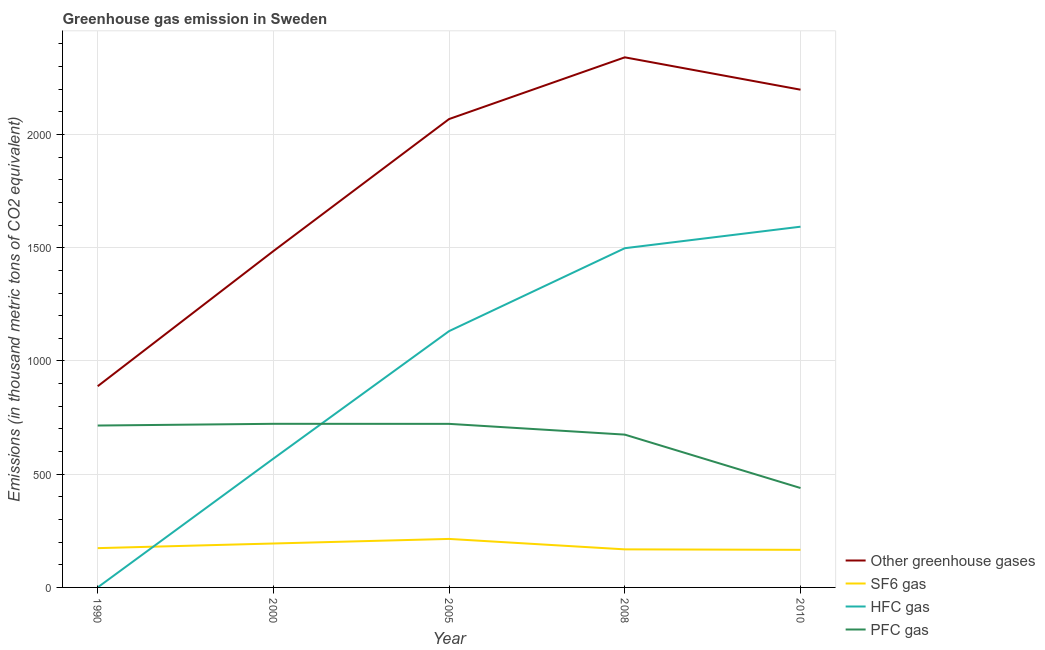What is the emission of greenhouse gases in 2000?
Give a very brief answer. 1485.3. Across all years, what is the maximum emission of pfc gas?
Your answer should be very brief. 722.5. What is the total emission of pfc gas in the graph?
Your response must be concise. 3273.5. What is the difference between the emission of pfc gas in 2008 and that in 2010?
Ensure brevity in your answer.  235.8. What is the difference between the emission of greenhouse gases in 2005 and the emission of hfc gas in 2008?
Provide a short and direct response. 570.4. What is the average emission of sf6 gas per year?
Ensure brevity in your answer.  183.16. In the year 2010, what is the difference between the emission of sf6 gas and emission of pfc gas?
Your response must be concise. -273. In how many years, is the emission of pfc gas greater than 800 thousand metric tons?
Offer a terse response. 0. What is the ratio of the emission of pfc gas in 2000 to that in 2005?
Ensure brevity in your answer.  1. What is the difference between the highest and the second highest emission of pfc gas?
Keep it short and to the point. 0.2. What is the difference between the highest and the lowest emission of hfc gas?
Your response must be concise. 1592.8. In how many years, is the emission of pfc gas greater than the average emission of pfc gas taken over all years?
Offer a terse response. 4. Is the sum of the emission of hfc gas in 2005 and 2008 greater than the maximum emission of sf6 gas across all years?
Your answer should be compact. Yes. Is it the case that in every year, the sum of the emission of greenhouse gases and emission of sf6 gas is greater than the emission of hfc gas?
Keep it short and to the point. Yes. Is the emission of greenhouse gases strictly greater than the emission of pfc gas over the years?
Give a very brief answer. Yes. Is the emission of pfc gas strictly less than the emission of sf6 gas over the years?
Keep it short and to the point. No. How many lines are there?
Provide a short and direct response. 4. What is the difference between two consecutive major ticks on the Y-axis?
Make the answer very short. 500. Does the graph contain any zero values?
Your answer should be very brief. No. Does the graph contain grids?
Offer a very short reply. Yes. Where does the legend appear in the graph?
Your answer should be compact. Bottom right. What is the title of the graph?
Your response must be concise. Greenhouse gas emission in Sweden. Does "Secondary schools" appear as one of the legend labels in the graph?
Keep it short and to the point. No. What is the label or title of the Y-axis?
Offer a very short reply. Emissions (in thousand metric tons of CO2 equivalent). What is the Emissions (in thousand metric tons of CO2 equivalent) in Other greenhouse gases in 1990?
Offer a very short reply. 888.6. What is the Emissions (in thousand metric tons of CO2 equivalent) in SF6 gas in 1990?
Offer a terse response. 173.5. What is the Emissions (in thousand metric tons of CO2 equivalent) of HFC gas in 1990?
Your response must be concise. 0.2. What is the Emissions (in thousand metric tons of CO2 equivalent) in PFC gas in 1990?
Offer a terse response. 714.9. What is the Emissions (in thousand metric tons of CO2 equivalent) in Other greenhouse gases in 2000?
Provide a short and direct response. 1485.3. What is the Emissions (in thousand metric tons of CO2 equivalent) of SF6 gas in 2000?
Your response must be concise. 194. What is the Emissions (in thousand metric tons of CO2 equivalent) in HFC gas in 2000?
Your answer should be very brief. 568.8. What is the Emissions (in thousand metric tons of CO2 equivalent) of PFC gas in 2000?
Give a very brief answer. 722.5. What is the Emissions (in thousand metric tons of CO2 equivalent) in Other greenhouse gases in 2005?
Your answer should be compact. 2068.4. What is the Emissions (in thousand metric tons of CO2 equivalent) of SF6 gas in 2005?
Provide a short and direct response. 214.2. What is the Emissions (in thousand metric tons of CO2 equivalent) of HFC gas in 2005?
Keep it short and to the point. 1131.9. What is the Emissions (in thousand metric tons of CO2 equivalent) of PFC gas in 2005?
Ensure brevity in your answer.  722.3. What is the Emissions (in thousand metric tons of CO2 equivalent) in Other greenhouse gases in 2008?
Offer a terse response. 2340.9. What is the Emissions (in thousand metric tons of CO2 equivalent) of SF6 gas in 2008?
Offer a terse response. 168.1. What is the Emissions (in thousand metric tons of CO2 equivalent) in HFC gas in 2008?
Offer a very short reply. 1498. What is the Emissions (in thousand metric tons of CO2 equivalent) of PFC gas in 2008?
Your answer should be very brief. 674.8. What is the Emissions (in thousand metric tons of CO2 equivalent) of Other greenhouse gases in 2010?
Ensure brevity in your answer.  2198. What is the Emissions (in thousand metric tons of CO2 equivalent) in SF6 gas in 2010?
Make the answer very short. 166. What is the Emissions (in thousand metric tons of CO2 equivalent) in HFC gas in 2010?
Your answer should be very brief. 1593. What is the Emissions (in thousand metric tons of CO2 equivalent) in PFC gas in 2010?
Your response must be concise. 439. Across all years, what is the maximum Emissions (in thousand metric tons of CO2 equivalent) in Other greenhouse gases?
Offer a terse response. 2340.9. Across all years, what is the maximum Emissions (in thousand metric tons of CO2 equivalent) in SF6 gas?
Ensure brevity in your answer.  214.2. Across all years, what is the maximum Emissions (in thousand metric tons of CO2 equivalent) of HFC gas?
Your response must be concise. 1593. Across all years, what is the maximum Emissions (in thousand metric tons of CO2 equivalent) in PFC gas?
Give a very brief answer. 722.5. Across all years, what is the minimum Emissions (in thousand metric tons of CO2 equivalent) in Other greenhouse gases?
Provide a succinct answer. 888.6. Across all years, what is the minimum Emissions (in thousand metric tons of CO2 equivalent) in SF6 gas?
Your answer should be very brief. 166. Across all years, what is the minimum Emissions (in thousand metric tons of CO2 equivalent) in PFC gas?
Ensure brevity in your answer.  439. What is the total Emissions (in thousand metric tons of CO2 equivalent) of Other greenhouse gases in the graph?
Offer a terse response. 8981.2. What is the total Emissions (in thousand metric tons of CO2 equivalent) in SF6 gas in the graph?
Ensure brevity in your answer.  915.8. What is the total Emissions (in thousand metric tons of CO2 equivalent) of HFC gas in the graph?
Offer a terse response. 4791.9. What is the total Emissions (in thousand metric tons of CO2 equivalent) in PFC gas in the graph?
Your response must be concise. 3273.5. What is the difference between the Emissions (in thousand metric tons of CO2 equivalent) in Other greenhouse gases in 1990 and that in 2000?
Your response must be concise. -596.7. What is the difference between the Emissions (in thousand metric tons of CO2 equivalent) of SF6 gas in 1990 and that in 2000?
Give a very brief answer. -20.5. What is the difference between the Emissions (in thousand metric tons of CO2 equivalent) of HFC gas in 1990 and that in 2000?
Your answer should be compact. -568.6. What is the difference between the Emissions (in thousand metric tons of CO2 equivalent) of Other greenhouse gases in 1990 and that in 2005?
Provide a short and direct response. -1179.8. What is the difference between the Emissions (in thousand metric tons of CO2 equivalent) in SF6 gas in 1990 and that in 2005?
Ensure brevity in your answer.  -40.7. What is the difference between the Emissions (in thousand metric tons of CO2 equivalent) of HFC gas in 1990 and that in 2005?
Provide a short and direct response. -1131.7. What is the difference between the Emissions (in thousand metric tons of CO2 equivalent) of Other greenhouse gases in 1990 and that in 2008?
Keep it short and to the point. -1452.3. What is the difference between the Emissions (in thousand metric tons of CO2 equivalent) of SF6 gas in 1990 and that in 2008?
Your response must be concise. 5.4. What is the difference between the Emissions (in thousand metric tons of CO2 equivalent) of HFC gas in 1990 and that in 2008?
Your answer should be very brief. -1497.8. What is the difference between the Emissions (in thousand metric tons of CO2 equivalent) of PFC gas in 1990 and that in 2008?
Provide a short and direct response. 40.1. What is the difference between the Emissions (in thousand metric tons of CO2 equivalent) of Other greenhouse gases in 1990 and that in 2010?
Your answer should be compact. -1309.4. What is the difference between the Emissions (in thousand metric tons of CO2 equivalent) of HFC gas in 1990 and that in 2010?
Your answer should be compact. -1592.8. What is the difference between the Emissions (in thousand metric tons of CO2 equivalent) in PFC gas in 1990 and that in 2010?
Keep it short and to the point. 275.9. What is the difference between the Emissions (in thousand metric tons of CO2 equivalent) of Other greenhouse gases in 2000 and that in 2005?
Keep it short and to the point. -583.1. What is the difference between the Emissions (in thousand metric tons of CO2 equivalent) in SF6 gas in 2000 and that in 2005?
Offer a very short reply. -20.2. What is the difference between the Emissions (in thousand metric tons of CO2 equivalent) in HFC gas in 2000 and that in 2005?
Your response must be concise. -563.1. What is the difference between the Emissions (in thousand metric tons of CO2 equivalent) in Other greenhouse gases in 2000 and that in 2008?
Your response must be concise. -855.6. What is the difference between the Emissions (in thousand metric tons of CO2 equivalent) in SF6 gas in 2000 and that in 2008?
Provide a short and direct response. 25.9. What is the difference between the Emissions (in thousand metric tons of CO2 equivalent) in HFC gas in 2000 and that in 2008?
Offer a very short reply. -929.2. What is the difference between the Emissions (in thousand metric tons of CO2 equivalent) in PFC gas in 2000 and that in 2008?
Make the answer very short. 47.7. What is the difference between the Emissions (in thousand metric tons of CO2 equivalent) of Other greenhouse gases in 2000 and that in 2010?
Offer a terse response. -712.7. What is the difference between the Emissions (in thousand metric tons of CO2 equivalent) of HFC gas in 2000 and that in 2010?
Make the answer very short. -1024.2. What is the difference between the Emissions (in thousand metric tons of CO2 equivalent) of PFC gas in 2000 and that in 2010?
Your answer should be very brief. 283.5. What is the difference between the Emissions (in thousand metric tons of CO2 equivalent) of Other greenhouse gases in 2005 and that in 2008?
Your answer should be very brief. -272.5. What is the difference between the Emissions (in thousand metric tons of CO2 equivalent) of SF6 gas in 2005 and that in 2008?
Offer a terse response. 46.1. What is the difference between the Emissions (in thousand metric tons of CO2 equivalent) of HFC gas in 2005 and that in 2008?
Provide a succinct answer. -366.1. What is the difference between the Emissions (in thousand metric tons of CO2 equivalent) in PFC gas in 2005 and that in 2008?
Your response must be concise. 47.5. What is the difference between the Emissions (in thousand metric tons of CO2 equivalent) of Other greenhouse gases in 2005 and that in 2010?
Your answer should be compact. -129.6. What is the difference between the Emissions (in thousand metric tons of CO2 equivalent) in SF6 gas in 2005 and that in 2010?
Provide a succinct answer. 48.2. What is the difference between the Emissions (in thousand metric tons of CO2 equivalent) in HFC gas in 2005 and that in 2010?
Give a very brief answer. -461.1. What is the difference between the Emissions (in thousand metric tons of CO2 equivalent) in PFC gas in 2005 and that in 2010?
Your answer should be very brief. 283.3. What is the difference between the Emissions (in thousand metric tons of CO2 equivalent) of Other greenhouse gases in 2008 and that in 2010?
Provide a succinct answer. 142.9. What is the difference between the Emissions (in thousand metric tons of CO2 equivalent) in HFC gas in 2008 and that in 2010?
Keep it short and to the point. -95. What is the difference between the Emissions (in thousand metric tons of CO2 equivalent) in PFC gas in 2008 and that in 2010?
Offer a terse response. 235.8. What is the difference between the Emissions (in thousand metric tons of CO2 equivalent) in Other greenhouse gases in 1990 and the Emissions (in thousand metric tons of CO2 equivalent) in SF6 gas in 2000?
Provide a short and direct response. 694.6. What is the difference between the Emissions (in thousand metric tons of CO2 equivalent) in Other greenhouse gases in 1990 and the Emissions (in thousand metric tons of CO2 equivalent) in HFC gas in 2000?
Provide a succinct answer. 319.8. What is the difference between the Emissions (in thousand metric tons of CO2 equivalent) in Other greenhouse gases in 1990 and the Emissions (in thousand metric tons of CO2 equivalent) in PFC gas in 2000?
Ensure brevity in your answer.  166.1. What is the difference between the Emissions (in thousand metric tons of CO2 equivalent) of SF6 gas in 1990 and the Emissions (in thousand metric tons of CO2 equivalent) of HFC gas in 2000?
Keep it short and to the point. -395.3. What is the difference between the Emissions (in thousand metric tons of CO2 equivalent) in SF6 gas in 1990 and the Emissions (in thousand metric tons of CO2 equivalent) in PFC gas in 2000?
Make the answer very short. -549. What is the difference between the Emissions (in thousand metric tons of CO2 equivalent) of HFC gas in 1990 and the Emissions (in thousand metric tons of CO2 equivalent) of PFC gas in 2000?
Ensure brevity in your answer.  -722.3. What is the difference between the Emissions (in thousand metric tons of CO2 equivalent) in Other greenhouse gases in 1990 and the Emissions (in thousand metric tons of CO2 equivalent) in SF6 gas in 2005?
Your response must be concise. 674.4. What is the difference between the Emissions (in thousand metric tons of CO2 equivalent) in Other greenhouse gases in 1990 and the Emissions (in thousand metric tons of CO2 equivalent) in HFC gas in 2005?
Make the answer very short. -243.3. What is the difference between the Emissions (in thousand metric tons of CO2 equivalent) of Other greenhouse gases in 1990 and the Emissions (in thousand metric tons of CO2 equivalent) of PFC gas in 2005?
Make the answer very short. 166.3. What is the difference between the Emissions (in thousand metric tons of CO2 equivalent) in SF6 gas in 1990 and the Emissions (in thousand metric tons of CO2 equivalent) in HFC gas in 2005?
Provide a short and direct response. -958.4. What is the difference between the Emissions (in thousand metric tons of CO2 equivalent) of SF6 gas in 1990 and the Emissions (in thousand metric tons of CO2 equivalent) of PFC gas in 2005?
Provide a succinct answer. -548.8. What is the difference between the Emissions (in thousand metric tons of CO2 equivalent) of HFC gas in 1990 and the Emissions (in thousand metric tons of CO2 equivalent) of PFC gas in 2005?
Provide a short and direct response. -722.1. What is the difference between the Emissions (in thousand metric tons of CO2 equivalent) in Other greenhouse gases in 1990 and the Emissions (in thousand metric tons of CO2 equivalent) in SF6 gas in 2008?
Your answer should be very brief. 720.5. What is the difference between the Emissions (in thousand metric tons of CO2 equivalent) in Other greenhouse gases in 1990 and the Emissions (in thousand metric tons of CO2 equivalent) in HFC gas in 2008?
Keep it short and to the point. -609.4. What is the difference between the Emissions (in thousand metric tons of CO2 equivalent) in Other greenhouse gases in 1990 and the Emissions (in thousand metric tons of CO2 equivalent) in PFC gas in 2008?
Provide a succinct answer. 213.8. What is the difference between the Emissions (in thousand metric tons of CO2 equivalent) in SF6 gas in 1990 and the Emissions (in thousand metric tons of CO2 equivalent) in HFC gas in 2008?
Provide a succinct answer. -1324.5. What is the difference between the Emissions (in thousand metric tons of CO2 equivalent) of SF6 gas in 1990 and the Emissions (in thousand metric tons of CO2 equivalent) of PFC gas in 2008?
Offer a terse response. -501.3. What is the difference between the Emissions (in thousand metric tons of CO2 equivalent) in HFC gas in 1990 and the Emissions (in thousand metric tons of CO2 equivalent) in PFC gas in 2008?
Your response must be concise. -674.6. What is the difference between the Emissions (in thousand metric tons of CO2 equivalent) in Other greenhouse gases in 1990 and the Emissions (in thousand metric tons of CO2 equivalent) in SF6 gas in 2010?
Offer a terse response. 722.6. What is the difference between the Emissions (in thousand metric tons of CO2 equivalent) in Other greenhouse gases in 1990 and the Emissions (in thousand metric tons of CO2 equivalent) in HFC gas in 2010?
Offer a very short reply. -704.4. What is the difference between the Emissions (in thousand metric tons of CO2 equivalent) in Other greenhouse gases in 1990 and the Emissions (in thousand metric tons of CO2 equivalent) in PFC gas in 2010?
Ensure brevity in your answer.  449.6. What is the difference between the Emissions (in thousand metric tons of CO2 equivalent) of SF6 gas in 1990 and the Emissions (in thousand metric tons of CO2 equivalent) of HFC gas in 2010?
Ensure brevity in your answer.  -1419.5. What is the difference between the Emissions (in thousand metric tons of CO2 equivalent) of SF6 gas in 1990 and the Emissions (in thousand metric tons of CO2 equivalent) of PFC gas in 2010?
Your answer should be very brief. -265.5. What is the difference between the Emissions (in thousand metric tons of CO2 equivalent) in HFC gas in 1990 and the Emissions (in thousand metric tons of CO2 equivalent) in PFC gas in 2010?
Ensure brevity in your answer.  -438.8. What is the difference between the Emissions (in thousand metric tons of CO2 equivalent) in Other greenhouse gases in 2000 and the Emissions (in thousand metric tons of CO2 equivalent) in SF6 gas in 2005?
Your answer should be very brief. 1271.1. What is the difference between the Emissions (in thousand metric tons of CO2 equivalent) in Other greenhouse gases in 2000 and the Emissions (in thousand metric tons of CO2 equivalent) in HFC gas in 2005?
Provide a short and direct response. 353.4. What is the difference between the Emissions (in thousand metric tons of CO2 equivalent) in Other greenhouse gases in 2000 and the Emissions (in thousand metric tons of CO2 equivalent) in PFC gas in 2005?
Provide a succinct answer. 763. What is the difference between the Emissions (in thousand metric tons of CO2 equivalent) in SF6 gas in 2000 and the Emissions (in thousand metric tons of CO2 equivalent) in HFC gas in 2005?
Your response must be concise. -937.9. What is the difference between the Emissions (in thousand metric tons of CO2 equivalent) of SF6 gas in 2000 and the Emissions (in thousand metric tons of CO2 equivalent) of PFC gas in 2005?
Your answer should be compact. -528.3. What is the difference between the Emissions (in thousand metric tons of CO2 equivalent) of HFC gas in 2000 and the Emissions (in thousand metric tons of CO2 equivalent) of PFC gas in 2005?
Your response must be concise. -153.5. What is the difference between the Emissions (in thousand metric tons of CO2 equivalent) of Other greenhouse gases in 2000 and the Emissions (in thousand metric tons of CO2 equivalent) of SF6 gas in 2008?
Your answer should be compact. 1317.2. What is the difference between the Emissions (in thousand metric tons of CO2 equivalent) in Other greenhouse gases in 2000 and the Emissions (in thousand metric tons of CO2 equivalent) in PFC gas in 2008?
Your response must be concise. 810.5. What is the difference between the Emissions (in thousand metric tons of CO2 equivalent) of SF6 gas in 2000 and the Emissions (in thousand metric tons of CO2 equivalent) of HFC gas in 2008?
Give a very brief answer. -1304. What is the difference between the Emissions (in thousand metric tons of CO2 equivalent) in SF6 gas in 2000 and the Emissions (in thousand metric tons of CO2 equivalent) in PFC gas in 2008?
Offer a very short reply. -480.8. What is the difference between the Emissions (in thousand metric tons of CO2 equivalent) in HFC gas in 2000 and the Emissions (in thousand metric tons of CO2 equivalent) in PFC gas in 2008?
Offer a terse response. -106. What is the difference between the Emissions (in thousand metric tons of CO2 equivalent) in Other greenhouse gases in 2000 and the Emissions (in thousand metric tons of CO2 equivalent) in SF6 gas in 2010?
Offer a terse response. 1319.3. What is the difference between the Emissions (in thousand metric tons of CO2 equivalent) of Other greenhouse gases in 2000 and the Emissions (in thousand metric tons of CO2 equivalent) of HFC gas in 2010?
Give a very brief answer. -107.7. What is the difference between the Emissions (in thousand metric tons of CO2 equivalent) in Other greenhouse gases in 2000 and the Emissions (in thousand metric tons of CO2 equivalent) in PFC gas in 2010?
Make the answer very short. 1046.3. What is the difference between the Emissions (in thousand metric tons of CO2 equivalent) of SF6 gas in 2000 and the Emissions (in thousand metric tons of CO2 equivalent) of HFC gas in 2010?
Your answer should be compact. -1399. What is the difference between the Emissions (in thousand metric tons of CO2 equivalent) of SF6 gas in 2000 and the Emissions (in thousand metric tons of CO2 equivalent) of PFC gas in 2010?
Give a very brief answer. -245. What is the difference between the Emissions (in thousand metric tons of CO2 equivalent) in HFC gas in 2000 and the Emissions (in thousand metric tons of CO2 equivalent) in PFC gas in 2010?
Your answer should be compact. 129.8. What is the difference between the Emissions (in thousand metric tons of CO2 equivalent) of Other greenhouse gases in 2005 and the Emissions (in thousand metric tons of CO2 equivalent) of SF6 gas in 2008?
Offer a terse response. 1900.3. What is the difference between the Emissions (in thousand metric tons of CO2 equivalent) in Other greenhouse gases in 2005 and the Emissions (in thousand metric tons of CO2 equivalent) in HFC gas in 2008?
Your answer should be very brief. 570.4. What is the difference between the Emissions (in thousand metric tons of CO2 equivalent) of Other greenhouse gases in 2005 and the Emissions (in thousand metric tons of CO2 equivalent) of PFC gas in 2008?
Your answer should be very brief. 1393.6. What is the difference between the Emissions (in thousand metric tons of CO2 equivalent) in SF6 gas in 2005 and the Emissions (in thousand metric tons of CO2 equivalent) in HFC gas in 2008?
Provide a succinct answer. -1283.8. What is the difference between the Emissions (in thousand metric tons of CO2 equivalent) in SF6 gas in 2005 and the Emissions (in thousand metric tons of CO2 equivalent) in PFC gas in 2008?
Provide a succinct answer. -460.6. What is the difference between the Emissions (in thousand metric tons of CO2 equivalent) of HFC gas in 2005 and the Emissions (in thousand metric tons of CO2 equivalent) of PFC gas in 2008?
Your response must be concise. 457.1. What is the difference between the Emissions (in thousand metric tons of CO2 equivalent) of Other greenhouse gases in 2005 and the Emissions (in thousand metric tons of CO2 equivalent) of SF6 gas in 2010?
Ensure brevity in your answer.  1902.4. What is the difference between the Emissions (in thousand metric tons of CO2 equivalent) of Other greenhouse gases in 2005 and the Emissions (in thousand metric tons of CO2 equivalent) of HFC gas in 2010?
Keep it short and to the point. 475.4. What is the difference between the Emissions (in thousand metric tons of CO2 equivalent) of Other greenhouse gases in 2005 and the Emissions (in thousand metric tons of CO2 equivalent) of PFC gas in 2010?
Provide a succinct answer. 1629.4. What is the difference between the Emissions (in thousand metric tons of CO2 equivalent) in SF6 gas in 2005 and the Emissions (in thousand metric tons of CO2 equivalent) in HFC gas in 2010?
Provide a short and direct response. -1378.8. What is the difference between the Emissions (in thousand metric tons of CO2 equivalent) of SF6 gas in 2005 and the Emissions (in thousand metric tons of CO2 equivalent) of PFC gas in 2010?
Your answer should be very brief. -224.8. What is the difference between the Emissions (in thousand metric tons of CO2 equivalent) in HFC gas in 2005 and the Emissions (in thousand metric tons of CO2 equivalent) in PFC gas in 2010?
Keep it short and to the point. 692.9. What is the difference between the Emissions (in thousand metric tons of CO2 equivalent) in Other greenhouse gases in 2008 and the Emissions (in thousand metric tons of CO2 equivalent) in SF6 gas in 2010?
Make the answer very short. 2174.9. What is the difference between the Emissions (in thousand metric tons of CO2 equivalent) of Other greenhouse gases in 2008 and the Emissions (in thousand metric tons of CO2 equivalent) of HFC gas in 2010?
Provide a succinct answer. 747.9. What is the difference between the Emissions (in thousand metric tons of CO2 equivalent) of Other greenhouse gases in 2008 and the Emissions (in thousand metric tons of CO2 equivalent) of PFC gas in 2010?
Make the answer very short. 1901.9. What is the difference between the Emissions (in thousand metric tons of CO2 equivalent) of SF6 gas in 2008 and the Emissions (in thousand metric tons of CO2 equivalent) of HFC gas in 2010?
Make the answer very short. -1424.9. What is the difference between the Emissions (in thousand metric tons of CO2 equivalent) in SF6 gas in 2008 and the Emissions (in thousand metric tons of CO2 equivalent) in PFC gas in 2010?
Your response must be concise. -270.9. What is the difference between the Emissions (in thousand metric tons of CO2 equivalent) of HFC gas in 2008 and the Emissions (in thousand metric tons of CO2 equivalent) of PFC gas in 2010?
Make the answer very short. 1059. What is the average Emissions (in thousand metric tons of CO2 equivalent) of Other greenhouse gases per year?
Provide a succinct answer. 1796.24. What is the average Emissions (in thousand metric tons of CO2 equivalent) in SF6 gas per year?
Your answer should be compact. 183.16. What is the average Emissions (in thousand metric tons of CO2 equivalent) of HFC gas per year?
Provide a short and direct response. 958.38. What is the average Emissions (in thousand metric tons of CO2 equivalent) of PFC gas per year?
Keep it short and to the point. 654.7. In the year 1990, what is the difference between the Emissions (in thousand metric tons of CO2 equivalent) of Other greenhouse gases and Emissions (in thousand metric tons of CO2 equivalent) of SF6 gas?
Provide a short and direct response. 715.1. In the year 1990, what is the difference between the Emissions (in thousand metric tons of CO2 equivalent) in Other greenhouse gases and Emissions (in thousand metric tons of CO2 equivalent) in HFC gas?
Offer a terse response. 888.4. In the year 1990, what is the difference between the Emissions (in thousand metric tons of CO2 equivalent) in Other greenhouse gases and Emissions (in thousand metric tons of CO2 equivalent) in PFC gas?
Make the answer very short. 173.7. In the year 1990, what is the difference between the Emissions (in thousand metric tons of CO2 equivalent) in SF6 gas and Emissions (in thousand metric tons of CO2 equivalent) in HFC gas?
Your answer should be very brief. 173.3. In the year 1990, what is the difference between the Emissions (in thousand metric tons of CO2 equivalent) in SF6 gas and Emissions (in thousand metric tons of CO2 equivalent) in PFC gas?
Provide a short and direct response. -541.4. In the year 1990, what is the difference between the Emissions (in thousand metric tons of CO2 equivalent) in HFC gas and Emissions (in thousand metric tons of CO2 equivalent) in PFC gas?
Give a very brief answer. -714.7. In the year 2000, what is the difference between the Emissions (in thousand metric tons of CO2 equivalent) of Other greenhouse gases and Emissions (in thousand metric tons of CO2 equivalent) of SF6 gas?
Make the answer very short. 1291.3. In the year 2000, what is the difference between the Emissions (in thousand metric tons of CO2 equivalent) in Other greenhouse gases and Emissions (in thousand metric tons of CO2 equivalent) in HFC gas?
Make the answer very short. 916.5. In the year 2000, what is the difference between the Emissions (in thousand metric tons of CO2 equivalent) in Other greenhouse gases and Emissions (in thousand metric tons of CO2 equivalent) in PFC gas?
Provide a succinct answer. 762.8. In the year 2000, what is the difference between the Emissions (in thousand metric tons of CO2 equivalent) in SF6 gas and Emissions (in thousand metric tons of CO2 equivalent) in HFC gas?
Make the answer very short. -374.8. In the year 2000, what is the difference between the Emissions (in thousand metric tons of CO2 equivalent) in SF6 gas and Emissions (in thousand metric tons of CO2 equivalent) in PFC gas?
Keep it short and to the point. -528.5. In the year 2000, what is the difference between the Emissions (in thousand metric tons of CO2 equivalent) in HFC gas and Emissions (in thousand metric tons of CO2 equivalent) in PFC gas?
Ensure brevity in your answer.  -153.7. In the year 2005, what is the difference between the Emissions (in thousand metric tons of CO2 equivalent) of Other greenhouse gases and Emissions (in thousand metric tons of CO2 equivalent) of SF6 gas?
Offer a very short reply. 1854.2. In the year 2005, what is the difference between the Emissions (in thousand metric tons of CO2 equivalent) of Other greenhouse gases and Emissions (in thousand metric tons of CO2 equivalent) of HFC gas?
Make the answer very short. 936.5. In the year 2005, what is the difference between the Emissions (in thousand metric tons of CO2 equivalent) in Other greenhouse gases and Emissions (in thousand metric tons of CO2 equivalent) in PFC gas?
Your answer should be very brief. 1346.1. In the year 2005, what is the difference between the Emissions (in thousand metric tons of CO2 equivalent) of SF6 gas and Emissions (in thousand metric tons of CO2 equivalent) of HFC gas?
Your answer should be very brief. -917.7. In the year 2005, what is the difference between the Emissions (in thousand metric tons of CO2 equivalent) in SF6 gas and Emissions (in thousand metric tons of CO2 equivalent) in PFC gas?
Offer a terse response. -508.1. In the year 2005, what is the difference between the Emissions (in thousand metric tons of CO2 equivalent) in HFC gas and Emissions (in thousand metric tons of CO2 equivalent) in PFC gas?
Offer a very short reply. 409.6. In the year 2008, what is the difference between the Emissions (in thousand metric tons of CO2 equivalent) in Other greenhouse gases and Emissions (in thousand metric tons of CO2 equivalent) in SF6 gas?
Make the answer very short. 2172.8. In the year 2008, what is the difference between the Emissions (in thousand metric tons of CO2 equivalent) in Other greenhouse gases and Emissions (in thousand metric tons of CO2 equivalent) in HFC gas?
Make the answer very short. 842.9. In the year 2008, what is the difference between the Emissions (in thousand metric tons of CO2 equivalent) in Other greenhouse gases and Emissions (in thousand metric tons of CO2 equivalent) in PFC gas?
Provide a short and direct response. 1666.1. In the year 2008, what is the difference between the Emissions (in thousand metric tons of CO2 equivalent) in SF6 gas and Emissions (in thousand metric tons of CO2 equivalent) in HFC gas?
Make the answer very short. -1329.9. In the year 2008, what is the difference between the Emissions (in thousand metric tons of CO2 equivalent) of SF6 gas and Emissions (in thousand metric tons of CO2 equivalent) of PFC gas?
Provide a succinct answer. -506.7. In the year 2008, what is the difference between the Emissions (in thousand metric tons of CO2 equivalent) of HFC gas and Emissions (in thousand metric tons of CO2 equivalent) of PFC gas?
Give a very brief answer. 823.2. In the year 2010, what is the difference between the Emissions (in thousand metric tons of CO2 equivalent) of Other greenhouse gases and Emissions (in thousand metric tons of CO2 equivalent) of SF6 gas?
Ensure brevity in your answer.  2032. In the year 2010, what is the difference between the Emissions (in thousand metric tons of CO2 equivalent) of Other greenhouse gases and Emissions (in thousand metric tons of CO2 equivalent) of HFC gas?
Give a very brief answer. 605. In the year 2010, what is the difference between the Emissions (in thousand metric tons of CO2 equivalent) in Other greenhouse gases and Emissions (in thousand metric tons of CO2 equivalent) in PFC gas?
Your response must be concise. 1759. In the year 2010, what is the difference between the Emissions (in thousand metric tons of CO2 equivalent) in SF6 gas and Emissions (in thousand metric tons of CO2 equivalent) in HFC gas?
Offer a terse response. -1427. In the year 2010, what is the difference between the Emissions (in thousand metric tons of CO2 equivalent) of SF6 gas and Emissions (in thousand metric tons of CO2 equivalent) of PFC gas?
Offer a terse response. -273. In the year 2010, what is the difference between the Emissions (in thousand metric tons of CO2 equivalent) in HFC gas and Emissions (in thousand metric tons of CO2 equivalent) in PFC gas?
Make the answer very short. 1154. What is the ratio of the Emissions (in thousand metric tons of CO2 equivalent) of Other greenhouse gases in 1990 to that in 2000?
Your answer should be compact. 0.6. What is the ratio of the Emissions (in thousand metric tons of CO2 equivalent) of SF6 gas in 1990 to that in 2000?
Offer a very short reply. 0.89. What is the ratio of the Emissions (in thousand metric tons of CO2 equivalent) of HFC gas in 1990 to that in 2000?
Offer a very short reply. 0. What is the ratio of the Emissions (in thousand metric tons of CO2 equivalent) in PFC gas in 1990 to that in 2000?
Provide a short and direct response. 0.99. What is the ratio of the Emissions (in thousand metric tons of CO2 equivalent) in Other greenhouse gases in 1990 to that in 2005?
Your response must be concise. 0.43. What is the ratio of the Emissions (in thousand metric tons of CO2 equivalent) of SF6 gas in 1990 to that in 2005?
Your response must be concise. 0.81. What is the ratio of the Emissions (in thousand metric tons of CO2 equivalent) of HFC gas in 1990 to that in 2005?
Offer a very short reply. 0. What is the ratio of the Emissions (in thousand metric tons of CO2 equivalent) of Other greenhouse gases in 1990 to that in 2008?
Your response must be concise. 0.38. What is the ratio of the Emissions (in thousand metric tons of CO2 equivalent) in SF6 gas in 1990 to that in 2008?
Your response must be concise. 1.03. What is the ratio of the Emissions (in thousand metric tons of CO2 equivalent) of PFC gas in 1990 to that in 2008?
Offer a terse response. 1.06. What is the ratio of the Emissions (in thousand metric tons of CO2 equivalent) in Other greenhouse gases in 1990 to that in 2010?
Offer a very short reply. 0.4. What is the ratio of the Emissions (in thousand metric tons of CO2 equivalent) of SF6 gas in 1990 to that in 2010?
Your answer should be compact. 1.05. What is the ratio of the Emissions (in thousand metric tons of CO2 equivalent) in PFC gas in 1990 to that in 2010?
Give a very brief answer. 1.63. What is the ratio of the Emissions (in thousand metric tons of CO2 equivalent) of Other greenhouse gases in 2000 to that in 2005?
Offer a very short reply. 0.72. What is the ratio of the Emissions (in thousand metric tons of CO2 equivalent) in SF6 gas in 2000 to that in 2005?
Give a very brief answer. 0.91. What is the ratio of the Emissions (in thousand metric tons of CO2 equivalent) in HFC gas in 2000 to that in 2005?
Give a very brief answer. 0.5. What is the ratio of the Emissions (in thousand metric tons of CO2 equivalent) of Other greenhouse gases in 2000 to that in 2008?
Make the answer very short. 0.63. What is the ratio of the Emissions (in thousand metric tons of CO2 equivalent) in SF6 gas in 2000 to that in 2008?
Offer a very short reply. 1.15. What is the ratio of the Emissions (in thousand metric tons of CO2 equivalent) in HFC gas in 2000 to that in 2008?
Your response must be concise. 0.38. What is the ratio of the Emissions (in thousand metric tons of CO2 equivalent) in PFC gas in 2000 to that in 2008?
Make the answer very short. 1.07. What is the ratio of the Emissions (in thousand metric tons of CO2 equivalent) in Other greenhouse gases in 2000 to that in 2010?
Your answer should be compact. 0.68. What is the ratio of the Emissions (in thousand metric tons of CO2 equivalent) of SF6 gas in 2000 to that in 2010?
Make the answer very short. 1.17. What is the ratio of the Emissions (in thousand metric tons of CO2 equivalent) in HFC gas in 2000 to that in 2010?
Offer a very short reply. 0.36. What is the ratio of the Emissions (in thousand metric tons of CO2 equivalent) in PFC gas in 2000 to that in 2010?
Provide a short and direct response. 1.65. What is the ratio of the Emissions (in thousand metric tons of CO2 equivalent) in Other greenhouse gases in 2005 to that in 2008?
Make the answer very short. 0.88. What is the ratio of the Emissions (in thousand metric tons of CO2 equivalent) in SF6 gas in 2005 to that in 2008?
Offer a very short reply. 1.27. What is the ratio of the Emissions (in thousand metric tons of CO2 equivalent) in HFC gas in 2005 to that in 2008?
Offer a very short reply. 0.76. What is the ratio of the Emissions (in thousand metric tons of CO2 equivalent) of PFC gas in 2005 to that in 2008?
Provide a succinct answer. 1.07. What is the ratio of the Emissions (in thousand metric tons of CO2 equivalent) in Other greenhouse gases in 2005 to that in 2010?
Provide a succinct answer. 0.94. What is the ratio of the Emissions (in thousand metric tons of CO2 equivalent) of SF6 gas in 2005 to that in 2010?
Give a very brief answer. 1.29. What is the ratio of the Emissions (in thousand metric tons of CO2 equivalent) in HFC gas in 2005 to that in 2010?
Make the answer very short. 0.71. What is the ratio of the Emissions (in thousand metric tons of CO2 equivalent) in PFC gas in 2005 to that in 2010?
Your answer should be compact. 1.65. What is the ratio of the Emissions (in thousand metric tons of CO2 equivalent) in Other greenhouse gases in 2008 to that in 2010?
Offer a very short reply. 1.06. What is the ratio of the Emissions (in thousand metric tons of CO2 equivalent) of SF6 gas in 2008 to that in 2010?
Your answer should be very brief. 1.01. What is the ratio of the Emissions (in thousand metric tons of CO2 equivalent) of HFC gas in 2008 to that in 2010?
Provide a succinct answer. 0.94. What is the ratio of the Emissions (in thousand metric tons of CO2 equivalent) in PFC gas in 2008 to that in 2010?
Your answer should be compact. 1.54. What is the difference between the highest and the second highest Emissions (in thousand metric tons of CO2 equivalent) of Other greenhouse gases?
Offer a terse response. 142.9. What is the difference between the highest and the second highest Emissions (in thousand metric tons of CO2 equivalent) of SF6 gas?
Provide a short and direct response. 20.2. What is the difference between the highest and the second highest Emissions (in thousand metric tons of CO2 equivalent) of HFC gas?
Ensure brevity in your answer.  95. What is the difference between the highest and the lowest Emissions (in thousand metric tons of CO2 equivalent) in Other greenhouse gases?
Give a very brief answer. 1452.3. What is the difference between the highest and the lowest Emissions (in thousand metric tons of CO2 equivalent) of SF6 gas?
Provide a succinct answer. 48.2. What is the difference between the highest and the lowest Emissions (in thousand metric tons of CO2 equivalent) of HFC gas?
Keep it short and to the point. 1592.8. What is the difference between the highest and the lowest Emissions (in thousand metric tons of CO2 equivalent) of PFC gas?
Keep it short and to the point. 283.5. 